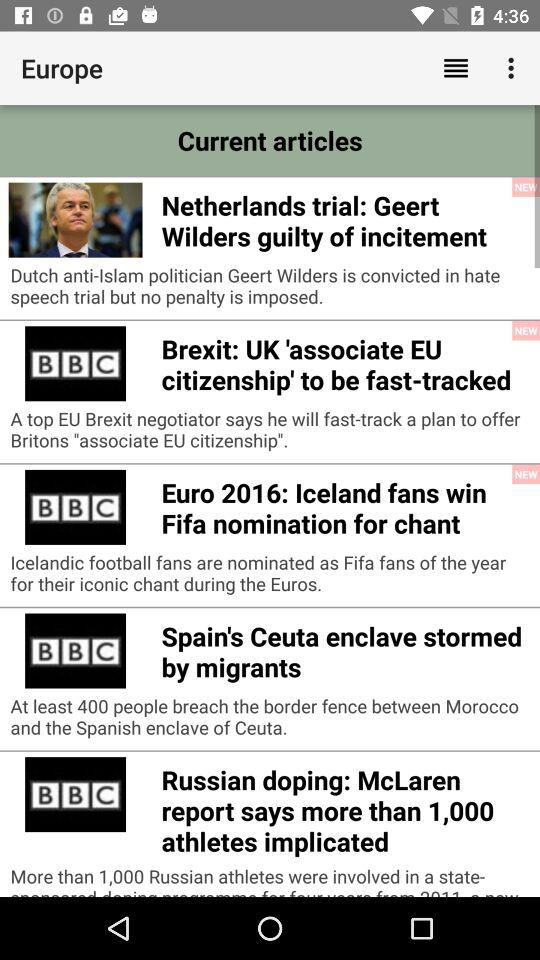How many athletes are implicated in the doping case? There are more than 1,000 athletes implicated in the doping case. 